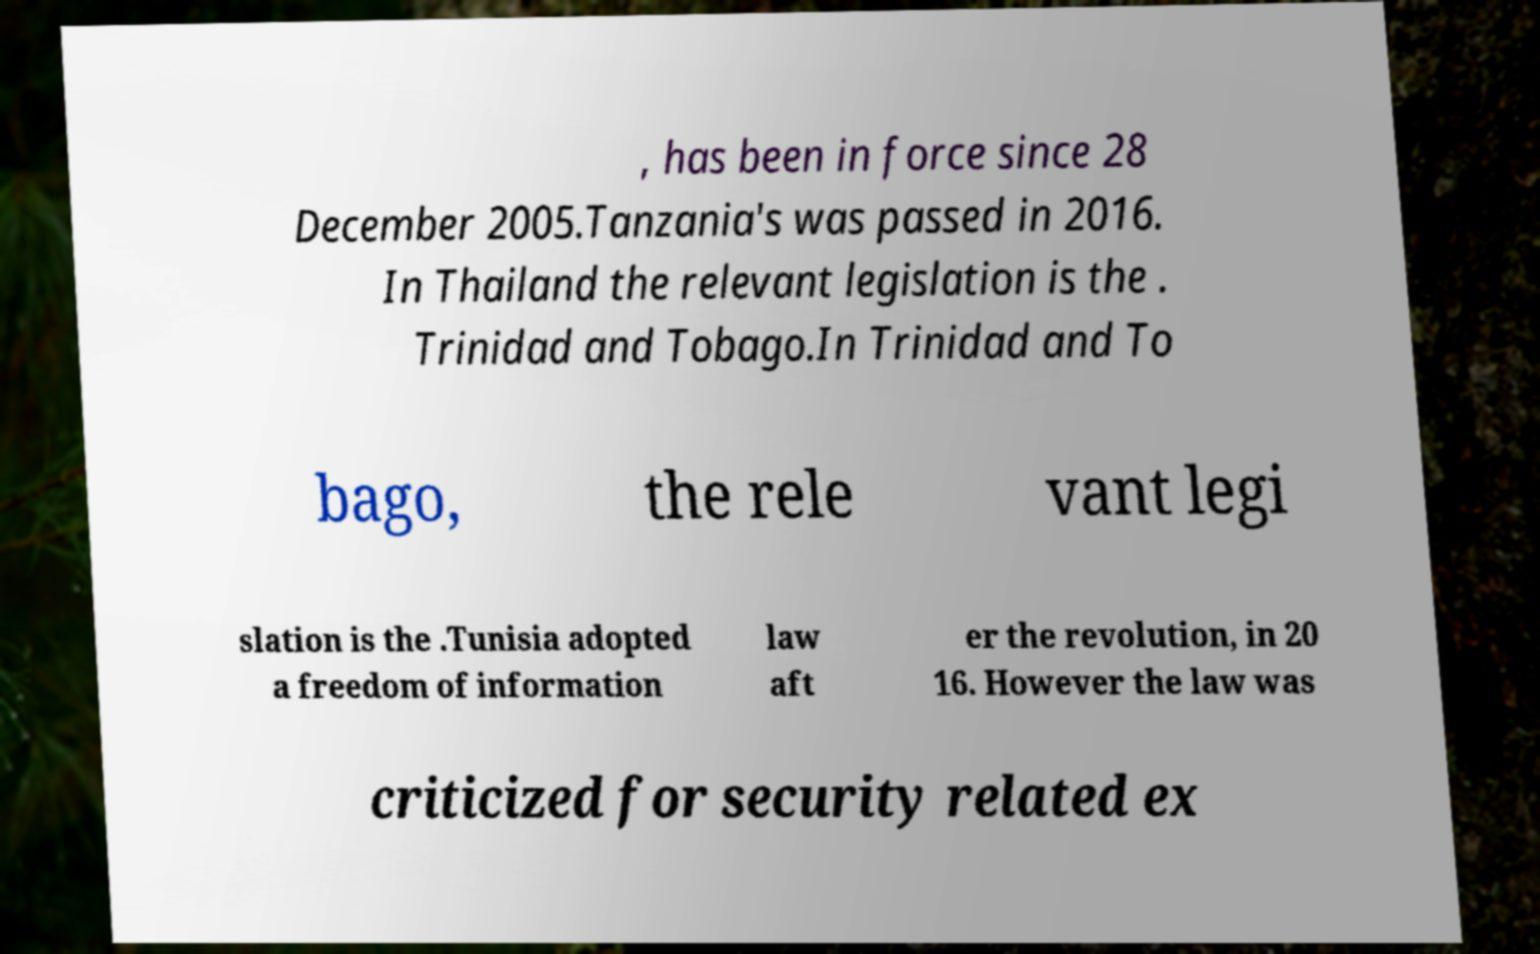For documentation purposes, I need the text within this image transcribed. Could you provide that? , has been in force since 28 December 2005.Tanzania's was passed in 2016. In Thailand the relevant legislation is the . Trinidad and Tobago.In Trinidad and To bago, the rele vant legi slation is the .Tunisia adopted a freedom of information law aft er the revolution, in 20 16. However the law was criticized for security related ex 